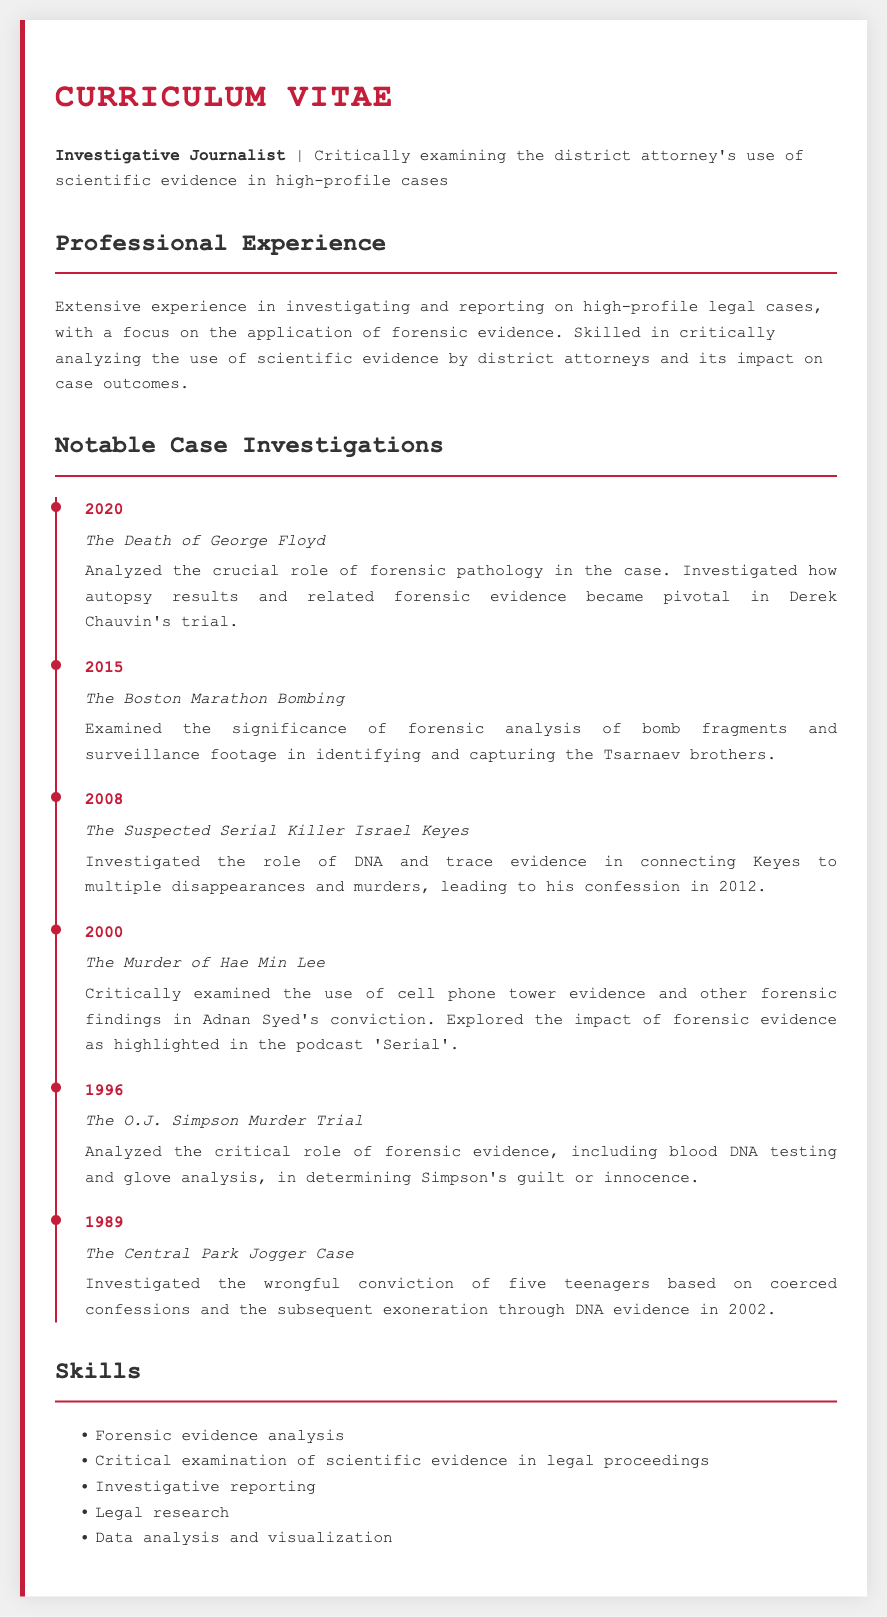What year did the George Floyd case occur? The document states that the key event in the George Floyd case took place in 2020.
Answer: 2020 Which case emphasized the role of DNA evidence leading to a confession in 2012? According to the document, the case investigated was that of Israel Keyes, which connected him to multiple disappearances and murders through DNA evidence.
Answer: Israel Keyes What was the focus of the investigation regarding Adnan Syed's conviction? The CV mentions that the investigation focused on the use of cell phone tower evidence and other forensic findings in the murder of Hae Min Lee.
Answer: Cell phone tower evidence In what year was the Boston Marathon Bombing case investigated? The investigation into the Boston Marathon Bombing occurred in 2015, as stated in the document.
Answer: 2015 How many years passed between the O.J. Simpson trial and the Central Park Jogger case? The document indicates that the O.J. Simpson trial took place in 1996 and the Central Park Jogger case in 1989, indicating a span of 7 years.
Answer: 7 years What scientific evidence was analyzed in the O.J. Simpson trial? The document notes that the forensic evidence analyzed included blood DNA testing and glove analysis in determining Simpson's guilt or innocence.
Answer: Blood DNA testing and glove analysis What is the main focus of the professional experience section? The professional experience section emphasizes the investigative approach to examining the district attorney's use of scientific evidence in high-profile cases.
Answer: Scientific evidence in high-profile cases What is one of the key skills mentioned in the CV? Among the listed skills, "Forensic evidence analysis" is highlighted as a key competency.
Answer: Forensic evidence analysis 